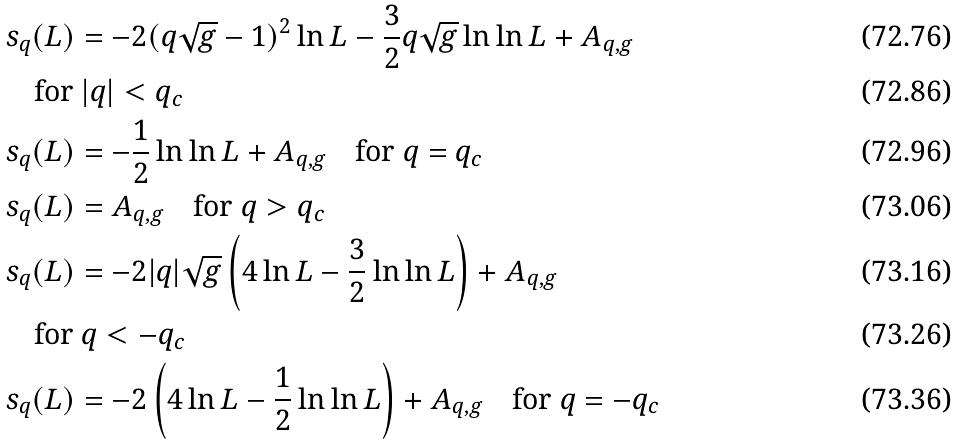Convert formula to latex. <formula><loc_0><loc_0><loc_500><loc_500>& s _ { q } ( L ) = - 2 ( q \sqrt { g } - 1 ) ^ { 2 } \ln L - \frac { 3 } { 2 } q \sqrt { g } \ln \ln L + A _ { q , g } \\ & \quad \text {for } | q | < q _ { c } \\ & s _ { q } ( L ) = - \frac { 1 } { 2 } \ln \ln L + A _ { q , g } \quad \text {for } q = q _ { c } \\ & s _ { q } ( L ) = A _ { q , g } \quad \text {for } q > q _ { c } \\ & s _ { q } ( L ) = - 2 | q | \sqrt { g } \left ( 4 \ln L - \frac { 3 } { 2 } \ln \ln L \right ) + A _ { q , g } \\ & \quad \text {for } q < - q _ { c } \\ & s _ { q } ( L ) = - 2 \left ( 4 \ln L - \frac { 1 } { 2 } \ln \ln L \right ) + A _ { q , g } \quad \text {for } q = - q _ { c }</formula> 